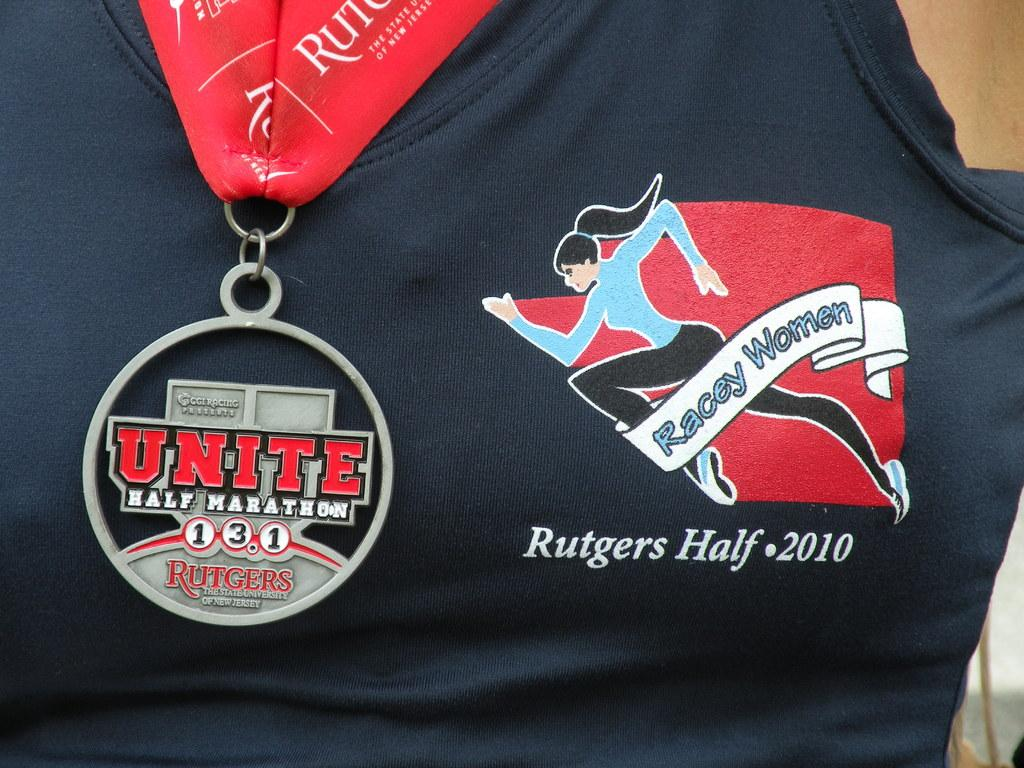<image>
Describe the image concisely. Black shirt for a racey woman and the rutger half 2010 